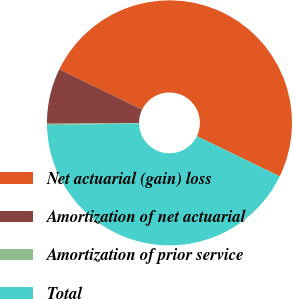Convert chart to OTSL. <chart><loc_0><loc_0><loc_500><loc_500><pie_chart><fcel>Net actuarial (gain) loss<fcel>Amortization of net actuarial<fcel>Amortization of prior service<fcel>Total<nl><fcel>50.0%<fcel>7.31%<fcel>0.19%<fcel>42.5%<nl></chart> 